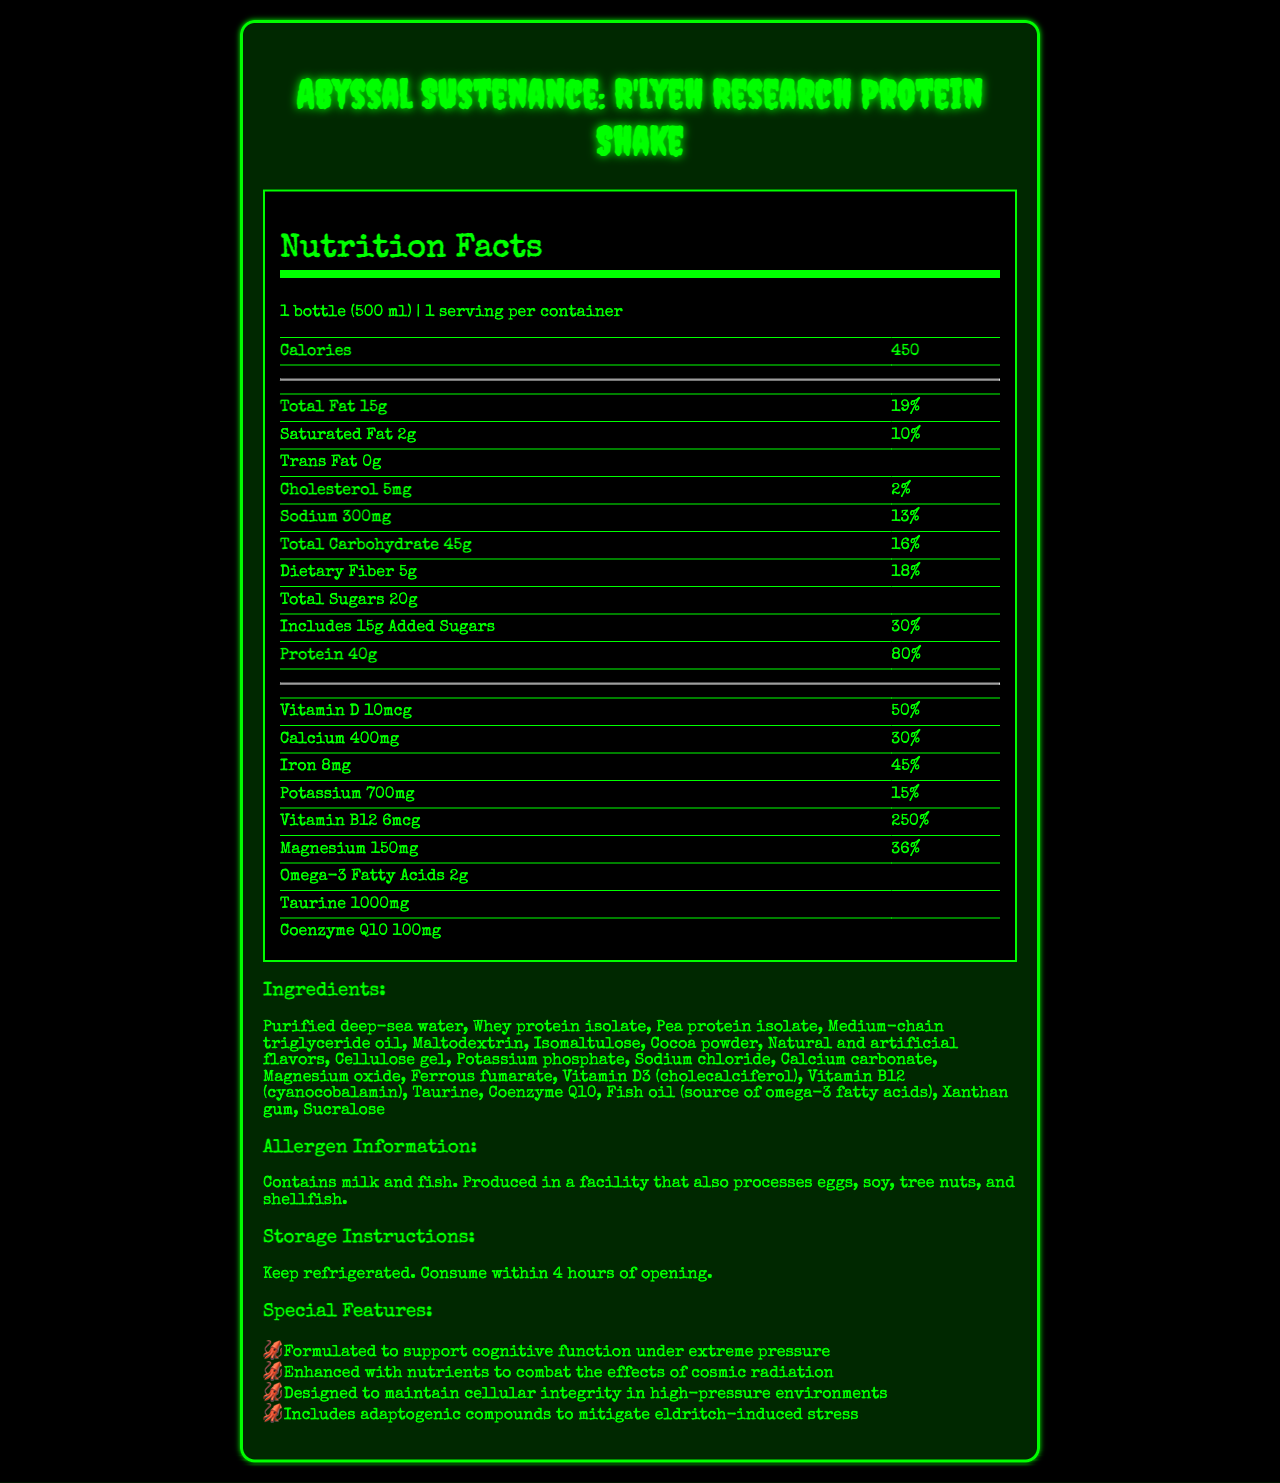what is the serving size of the protein shake? The serving size is indicated as "1 bottle (500 ml)" at the beginning of the nutrition facts section.
Answer: 1 bottle (500 ml) how many calories are in one bottle? The document states that the protein shake contains 450 calories per bottle.
Answer: 450 how much protein does the shake provide? The protein content is listed as 40 grams.
Answer: 40g what is the purpose of the adaptogenic compounds in the shake? The special features section mentions that the shake includes adaptogenic compounds to mitigate eldritch-induced stress.
Answer: To mitigate eldritch-induced stress how much dietary fiber is in one serving? The dietary fiber content is listed as 5 grams.
Answer: 5g what are the possible allergens in the shake? A. Milk and soy B. Eggs and shellfish C. Milk and fish D. Tree nuts and soy According to the allergen information, the shake contains milk and fish.
Answer: C. Milk and fish which vitamin has the highest daily value percentage in the shake? A. Vitamin D B. Calcium C. Iron D. Vitamin B12 The Vitamin B12 daily value percentage is 250%, the highest among the listed vitamins and minerals.
Answer: D. Vitamin B12 how long can the shake be consumed after opening? The storage instructions specify that the shake should be consumed within 4 hours of opening.
Answer: Within 4 hours does the shake contain any trans fat? The nutrition facts indicate that there is 0g of trans fat in the protein shake.
Answer: No summarize the main features of the R'lyeh Research Protein Shake. The R'lyeh Research Protein Shake is a specialized dietary solution tailored for the unique demands of deep-sea research. It provides a comprehensive nutrient profile to support physical and cognitive functions under extreme conditions.
Answer: The R'lyeh Research Protein Shake is designed for deep-sea researchers exploring Cthulhu's realm. It offers substantial nutritional support with 450 calories, 15g of total fat, 40g of protein, and various vitamins and minerals. It features ingredients like whey protein isolate, taurine, and Coenzyme Q10, and contains allergens such as milk and fish. The shake also includes adaptogenic compounds to reduce eldritch-induced stress and nutrients to combat cosmic radiation. what is the main source of omega-3 fatty acids in the shake? The ingredients list mentions fish oil as the source of omega-3 fatty acids.
Answer: Fish oil how much vitamin D is in each serving, and what percentage of the daily value does this represent? Each serving contains 10mcg of vitamin D, which is 50% of the daily value.
Answer: 10mcg, 50% for how many servings is this nutritional information provided? The document states that there is 1 serving per container.
Answer: 1 does the shake contain any shellfish? The allergen information indicates that the shake does not contain shellfish, but it is produced in a facility that processes shellfish.
Answer: No (But it is produced in a facility that processes shellfish) how does the shake support cognitive function under extreme pressure? The special features section states that the shake is designed to support cognitive function in high-pressure environments.
Answer: It is formulated with special nutrients to support cognitive function under extreme pressure. what is the purpose of adding Coenzyme Q10 to the shake? The document mentions Coenzyme Q10 as an ingredient but does not specify its purpose.
Answer: I don't know 